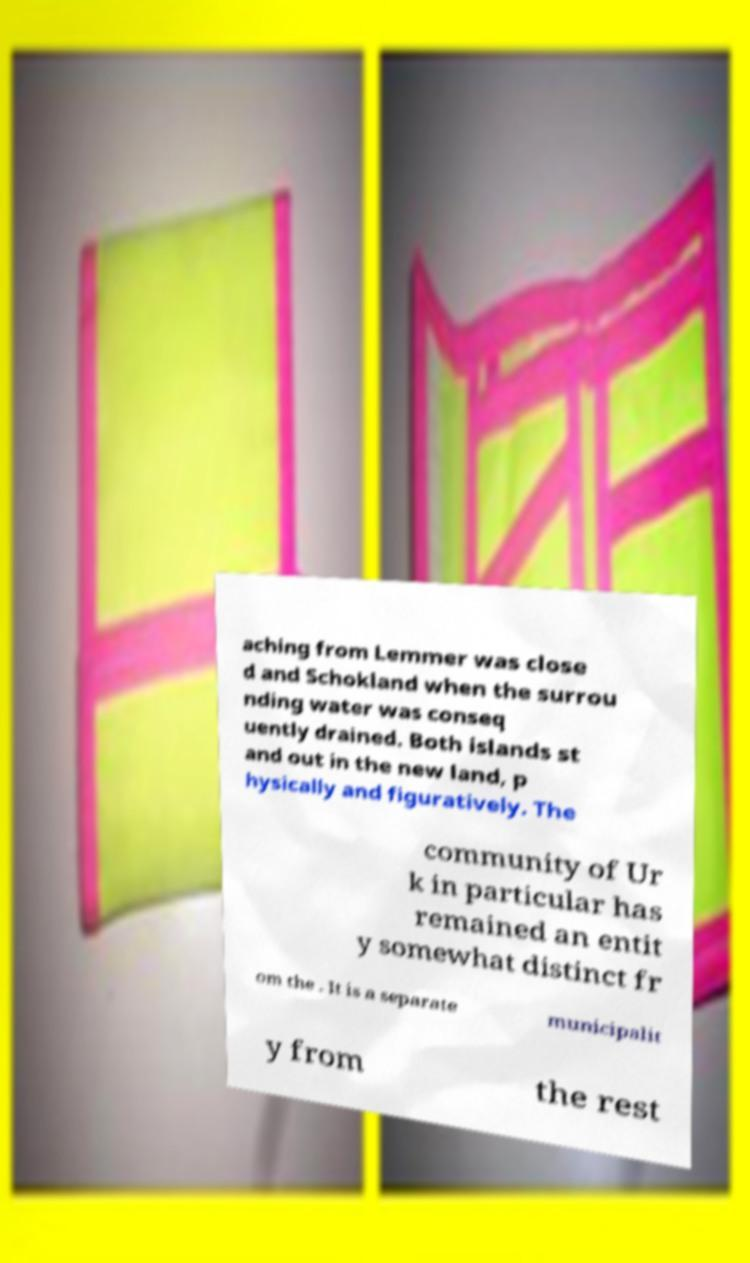I need the written content from this picture converted into text. Can you do that? aching from Lemmer was close d and Schokland when the surrou nding water was conseq uently drained. Both islands st and out in the new land, p hysically and figuratively. The community of Ur k in particular has remained an entit y somewhat distinct fr om the . It is a separate municipalit y from the rest 